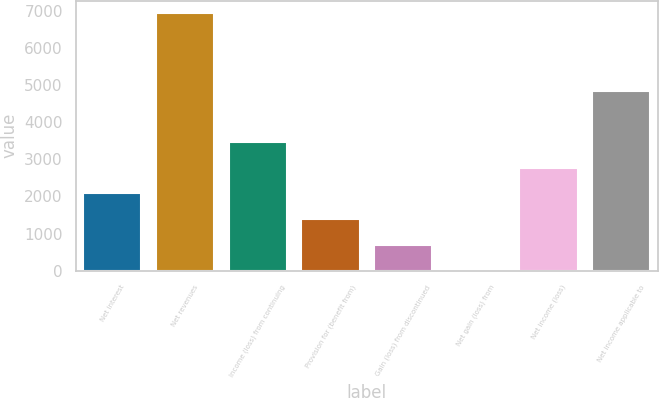Convert chart. <chart><loc_0><loc_0><loc_500><loc_500><bar_chart><fcel>Net interest<fcel>Net revenues<fcel>Income (loss) from continuing<fcel>Provision for (benefit from)<fcel>Gain (loss) from discontinued<fcel>Net gain (loss) from<fcel>Net income (loss)<fcel>Net income applicable to<nl><fcel>2087<fcel>6924<fcel>3469<fcel>1396<fcel>705<fcel>14<fcel>2778<fcel>4851<nl></chart> 